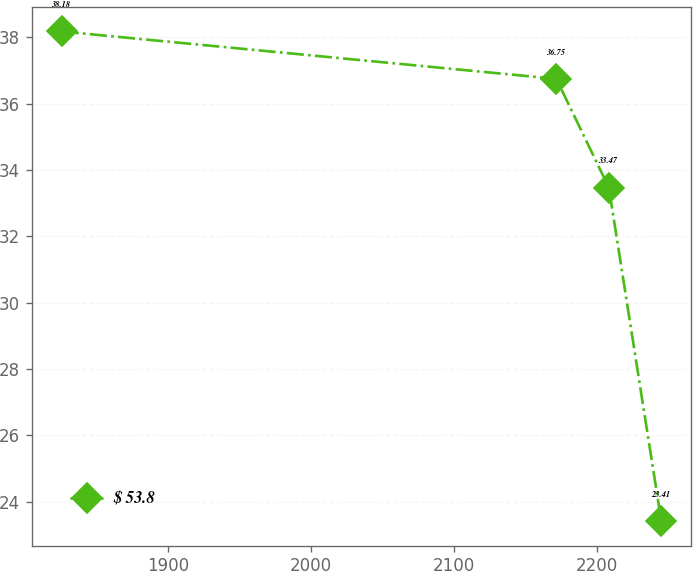<chart> <loc_0><loc_0><loc_500><loc_500><line_chart><ecel><fcel>$ 53.8<nl><fcel>1825.54<fcel>38.18<nl><fcel>2171.45<fcel>36.75<nl><fcel>2208.14<fcel>33.47<nl><fcel>2244.83<fcel>23.41<nl></chart> 